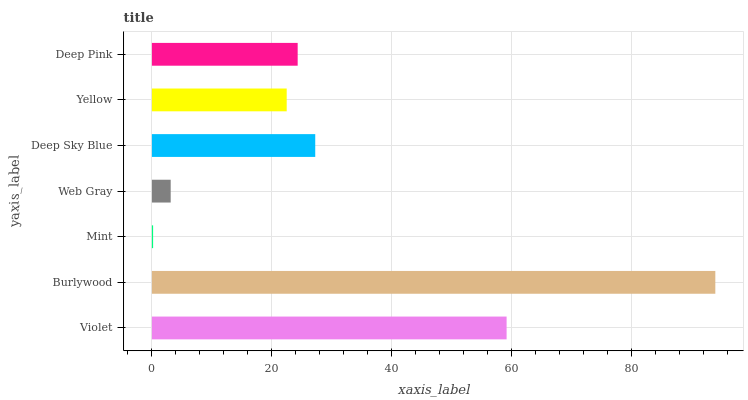Is Mint the minimum?
Answer yes or no. Yes. Is Burlywood the maximum?
Answer yes or no. Yes. Is Burlywood the minimum?
Answer yes or no. No. Is Mint the maximum?
Answer yes or no. No. Is Burlywood greater than Mint?
Answer yes or no. Yes. Is Mint less than Burlywood?
Answer yes or no. Yes. Is Mint greater than Burlywood?
Answer yes or no. No. Is Burlywood less than Mint?
Answer yes or no. No. Is Deep Pink the high median?
Answer yes or no. Yes. Is Deep Pink the low median?
Answer yes or no. Yes. Is Deep Sky Blue the high median?
Answer yes or no. No. Is Deep Sky Blue the low median?
Answer yes or no. No. 